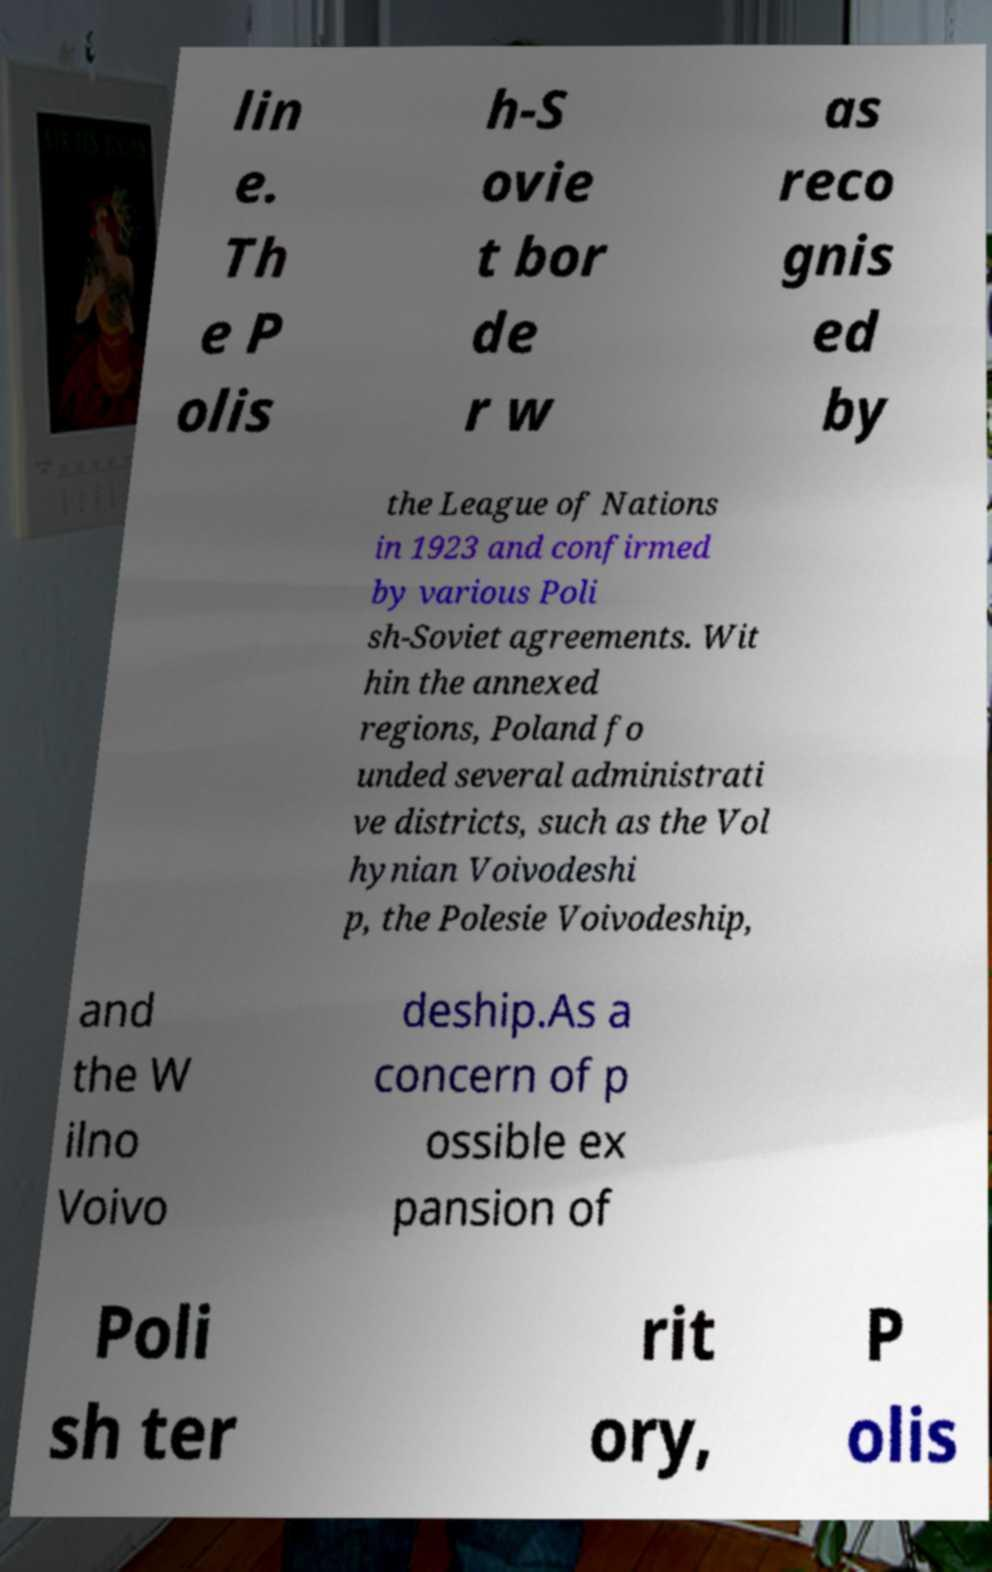I need the written content from this picture converted into text. Can you do that? lin e. Th e P olis h-S ovie t bor de r w as reco gnis ed by the League of Nations in 1923 and confirmed by various Poli sh-Soviet agreements. Wit hin the annexed regions, Poland fo unded several administrati ve districts, such as the Vol hynian Voivodeshi p, the Polesie Voivodeship, and the W ilno Voivo deship.As a concern of p ossible ex pansion of Poli sh ter rit ory, P olis 